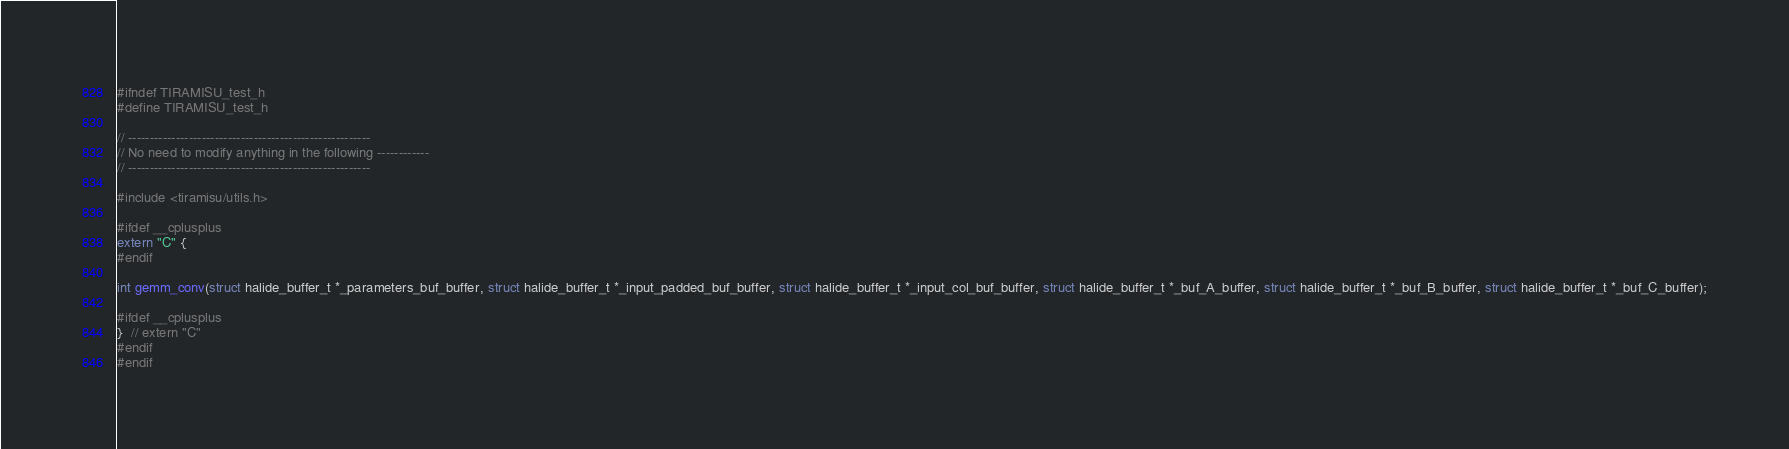<code> <loc_0><loc_0><loc_500><loc_500><_C_>#ifndef TIRAMISU_test_h
#define TIRAMISU_test_h

// --------------------------------------------------------
// No need to modify anything in the following ------------
// --------------------------------------------------------

#include <tiramisu/utils.h>

#ifdef __cplusplus
extern "C" {
#endif

int gemm_conv(struct halide_buffer_t *_parameters_buf_buffer, struct halide_buffer_t *_input_padded_buf_buffer, struct halide_buffer_t *_input_col_buf_buffer, struct halide_buffer_t *_buf_A_buffer, struct halide_buffer_t *_buf_B_buffer, struct halide_buffer_t *_buf_C_buffer);

#ifdef __cplusplus
}  // extern "C"
#endif
#endif
</code> 